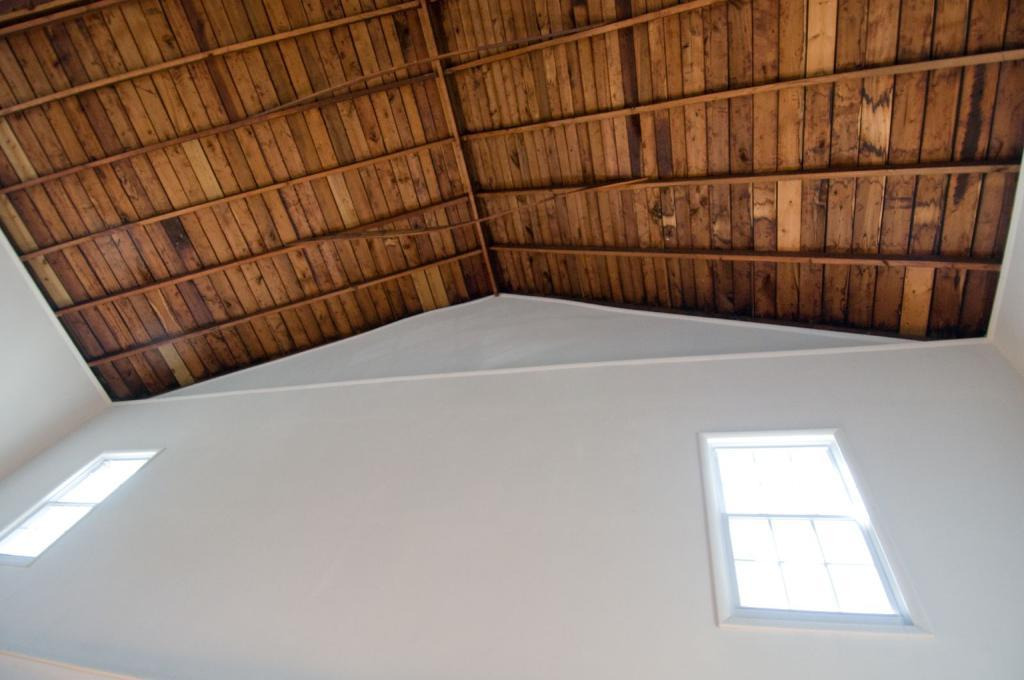What type of wall is visible in the image? There is a white wall in the image. How many glass windows can be seen in the image? There are two glass windows in the image. What material is the roof made of in the image? The roof in the image is made of wood. How many pizzas are being served on the ship in the image? There is no ship or pizzas present in the image. Can you describe the bite marks on the wooden roof in the image? There are no bite marks on the wooden roof in the image. 